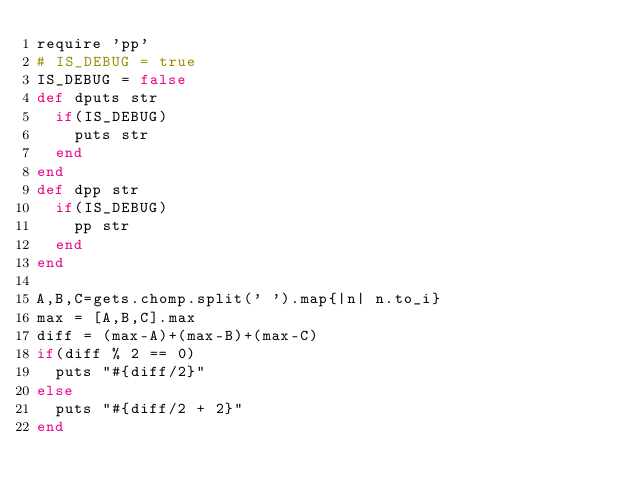<code> <loc_0><loc_0><loc_500><loc_500><_Ruby_>require 'pp'
# IS_DEBUG = true
IS_DEBUG = false
def dputs str
	if(IS_DEBUG)
		puts str
	end
end
def dpp str
	if(IS_DEBUG)
		pp str
	end
end

A,B,C=gets.chomp.split(' ').map{|n| n.to_i}
max = [A,B,C].max
diff = (max-A)+(max-B)+(max-C)
if(diff % 2 == 0)
	puts "#{diff/2}"
else
	puts "#{diff/2 + 2}"
end

</code> 